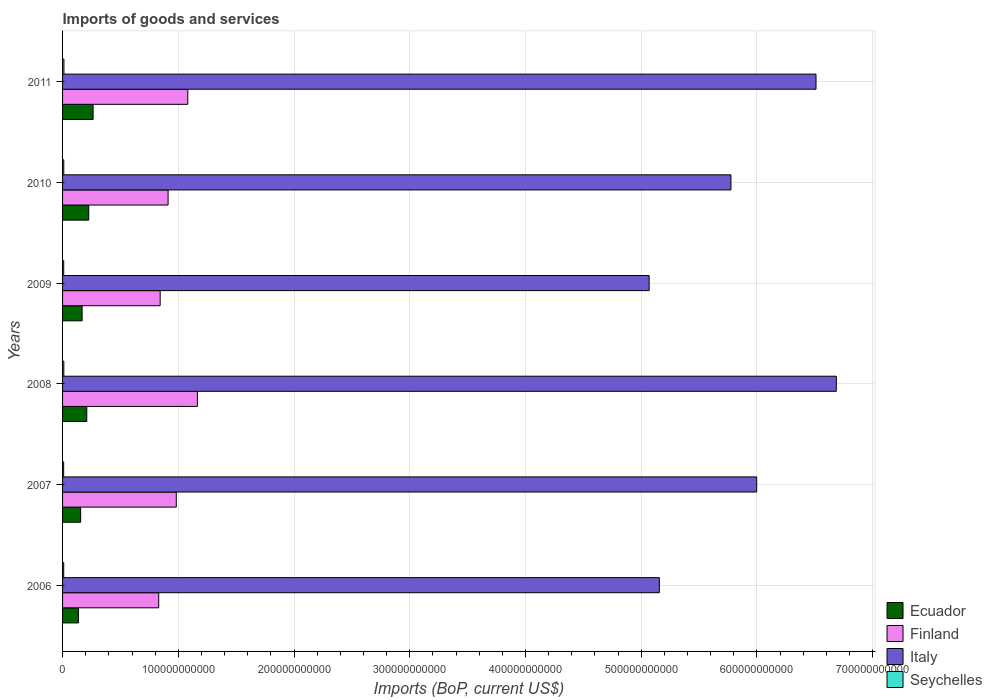How many different coloured bars are there?
Provide a short and direct response. 4. How many groups of bars are there?
Keep it short and to the point. 6. Are the number of bars per tick equal to the number of legend labels?
Give a very brief answer. Yes. How many bars are there on the 2nd tick from the top?
Keep it short and to the point. 4. What is the label of the 3rd group of bars from the top?
Offer a very short reply. 2009. In how many cases, is the number of bars for a given year not equal to the number of legend labels?
Offer a terse response. 0. What is the amount spent on imports in Ecuador in 2008?
Provide a succinct answer. 2.09e+1. Across all years, what is the maximum amount spent on imports in Finland?
Provide a short and direct response. 1.17e+11. Across all years, what is the minimum amount spent on imports in Ecuador?
Your answer should be very brief. 1.37e+1. In which year was the amount spent on imports in Finland minimum?
Offer a very short reply. 2006. What is the total amount spent on imports in Italy in the graph?
Keep it short and to the point. 3.52e+12. What is the difference between the amount spent on imports in Italy in 2007 and that in 2010?
Provide a short and direct response. 2.23e+1. What is the difference between the amount spent on imports in Finland in 2009 and the amount spent on imports in Italy in 2011?
Your response must be concise. -5.67e+11. What is the average amount spent on imports in Ecuador per year?
Give a very brief answer. 1.94e+1. In the year 2009, what is the difference between the amount spent on imports in Seychelles and amount spent on imports in Italy?
Keep it short and to the point. -5.06e+11. In how many years, is the amount spent on imports in Ecuador greater than 560000000000 US$?
Keep it short and to the point. 0. What is the ratio of the amount spent on imports in Ecuador in 2008 to that in 2009?
Keep it short and to the point. 1.24. Is the amount spent on imports in Seychelles in 2007 less than that in 2011?
Your answer should be very brief. Yes. Is the difference between the amount spent on imports in Seychelles in 2006 and 2008 greater than the difference between the amount spent on imports in Italy in 2006 and 2008?
Keep it short and to the point. Yes. What is the difference between the highest and the second highest amount spent on imports in Seychelles?
Your answer should be very brief. 9.66e+07. What is the difference between the highest and the lowest amount spent on imports in Ecuador?
Ensure brevity in your answer.  1.26e+1. Is it the case that in every year, the sum of the amount spent on imports in Seychelles and amount spent on imports in Finland is greater than the sum of amount spent on imports in Ecuador and amount spent on imports in Italy?
Make the answer very short. No. What does the 4th bar from the top in 2009 represents?
Make the answer very short. Ecuador. What does the 2nd bar from the bottom in 2008 represents?
Offer a very short reply. Finland. Is it the case that in every year, the sum of the amount spent on imports in Italy and amount spent on imports in Seychelles is greater than the amount spent on imports in Ecuador?
Your answer should be very brief. Yes. How many bars are there?
Give a very brief answer. 24. Are all the bars in the graph horizontal?
Offer a very short reply. Yes. How many years are there in the graph?
Provide a short and direct response. 6. What is the difference between two consecutive major ticks on the X-axis?
Provide a short and direct response. 1.00e+11. Does the graph contain any zero values?
Provide a succinct answer. No. Does the graph contain grids?
Offer a terse response. Yes. How many legend labels are there?
Your answer should be compact. 4. How are the legend labels stacked?
Your response must be concise. Vertical. What is the title of the graph?
Your response must be concise. Imports of goods and services. What is the label or title of the X-axis?
Your response must be concise. Imports (BoP, current US$). What is the Imports (BoP, current US$) in Ecuador in 2006?
Provide a succinct answer. 1.37e+1. What is the Imports (BoP, current US$) of Finland in 2006?
Provide a short and direct response. 8.31e+1. What is the Imports (BoP, current US$) of Italy in 2006?
Provide a succinct answer. 5.16e+11. What is the Imports (BoP, current US$) in Seychelles in 2006?
Ensure brevity in your answer.  9.85e+08. What is the Imports (BoP, current US$) in Ecuador in 2007?
Offer a very short reply. 1.56e+1. What is the Imports (BoP, current US$) of Finland in 2007?
Your response must be concise. 9.83e+1. What is the Imports (BoP, current US$) of Italy in 2007?
Provide a succinct answer. 6.00e+11. What is the Imports (BoP, current US$) in Seychelles in 2007?
Ensure brevity in your answer.  9.49e+08. What is the Imports (BoP, current US$) of Ecuador in 2008?
Give a very brief answer. 2.09e+1. What is the Imports (BoP, current US$) of Finland in 2008?
Offer a terse response. 1.17e+11. What is the Imports (BoP, current US$) in Italy in 2008?
Offer a terse response. 6.69e+11. What is the Imports (BoP, current US$) in Seychelles in 2008?
Offer a very short reply. 1.08e+09. What is the Imports (BoP, current US$) in Ecuador in 2009?
Your answer should be compact. 1.69e+1. What is the Imports (BoP, current US$) in Finland in 2009?
Make the answer very short. 8.43e+1. What is the Imports (BoP, current US$) in Italy in 2009?
Your response must be concise. 5.07e+11. What is the Imports (BoP, current US$) of Seychelles in 2009?
Offer a terse response. 9.92e+08. What is the Imports (BoP, current US$) of Ecuador in 2010?
Offer a terse response. 2.26e+1. What is the Imports (BoP, current US$) in Finland in 2010?
Provide a succinct answer. 9.12e+1. What is the Imports (BoP, current US$) of Italy in 2010?
Make the answer very short. 5.78e+11. What is the Imports (BoP, current US$) of Seychelles in 2010?
Provide a short and direct response. 1.05e+09. What is the Imports (BoP, current US$) in Ecuador in 2011?
Offer a very short reply. 2.64e+1. What is the Imports (BoP, current US$) of Finland in 2011?
Ensure brevity in your answer.  1.08e+11. What is the Imports (BoP, current US$) of Italy in 2011?
Keep it short and to the point. 6.51e+11. What is the Imports (BoP, current US$) in Seychelles in 2011?
Ensure brevity in your answer.  1.18e+09. Across all years, what is the maximum Imports (BoP, current US$) in Ecuador?
Your response must be concise. 2.64e+1. Across all years, what is the maximum Imports (BoP, current US$) of Finland?
Provide a succinct answer. 1.17e+11. Across all years, what is the maximum Imports (BoP, current US$) in Italy?
Make the answer very short. 6.69e+11. Across all years, what is the maximum Imports (BoP, current US$) in Seychelles?
Provide a short and direct response. 1.18e+09. Across all years, what is the minimum Imports (BoP, current US$) of Ecuador?
Offer a terse response. 1.37e+1. Across all years, what is the minimum Imports (BoP, current US$) in Finland?
Ensure brevity in your answer.  8.31e+1. Across all years, what is the minimum Imports (BoP, current US$) of Italy?
Make the answer very short. 5.07e+11. Across all years, what is the minimum Imports (BoP, current US$) of Seychelles?
Your answer should be very brief. 9.49e+08. What is the total Imports (BoP, current US$) in Ecuador in the graph?
Keep it short and to the point. 1.16e+11. What is the total Imports (BoP, current US$) in Finland in the graph?
Your answer should be very brief. 5.82e+11. What is the total Imports (BoP, current US$) in Italy in the graph?
Ensure brevity in your answer.  3.52e+12. What is the total Imports (BoP, current US$) in Seychelles in the graph?
Offer a very short reply. 6.24e+09. What is the difference between the Imports (BoP, current US$) of Ecuador in 2006 and that in 2007?
Give a very brief answer. -1.87e+09. What is the difference between the Imports (BoP, current US$) of Finland in 2006 and that in 2007?
Your response must be concise. -1.52e+1. What is the difference between the Imports (BoP, current US$) of Italy in 2006 and that in 2007?
Give a very brief answer. -8.41e+1. What is the difference between the Imports (BoP, current US$) in Seychelles in 2006 and that in 2007?
Provide a short and direct response. 3.58e+07. What is the difference between the Imports (BoP, current US$) in Ecuador in 2006 and that in 2008?
Give a very brief answer. -7.18e+09. What is the difference between the Imports (BoP, current US$) in Finland in 2006 and that in 2008?
Ensure brevity in your answer.  -3.34e+1. What is the difference between the Imports (BoP, current US$) of Italy in 2006 and that in 2008?
Provide a short and direct response. -1.53e+11. What is the difference between the Imports (BoP, current US$) in Seychelles in 2006 and that in 2008?
Keep it short and to the point. -9.99e+07. What is the difference between the Imports (BoP, current US$) of Ecuador in 2006 and that in 2009?
Your response must be concise. -3.14e+09. What is the difference between the Imports (BoP, current US$) in Finland in 2006 and that in 2009?
Your answer should be very brief. -1.26e+09. What is the difference between the Imports (BoP, current US$) of Italy in 2006 and that in 2009?
Keep it short and to the point. 8.82e+09. What is the difference between the Imports (BoP, current US$) in Seychelles in 2006 and that in 2009?
Provide a short and direct response. -7.03e+06. What is the difference between the Imports (BoP, current US$) in Ecuador in 2006 and that in 2010?
Give a very brief answer. -8.89e+09. What is the difference between the Imports (BoP, current US$) in Finland in 2006 and that in 2010?
Offer a very short reply. -8.11e+09. What is the difference between the Imports (BoP, current US$) in Italy in 2006 and that in 2010?
Provide a short and direct response. -6.18e+1. What is the difference between the Imports (BoP, current US$) of Seychelles in 2006 and that in 2010?
Your response must be concise. -6.32e+07. What is the difference between the Imports (BoP, current US$) of Ecuador in 2006 and that in 2011?
Your answer should be very brief. -1.26e+1. What is the difference between the Imports (BoP, current US$) of Finland in 2006 and that in 2011?
Your answer should be very brief. -2.51e+1. What is the difference between the Imports (BoP, current US$) in Italy in 2006 and that in 2011?
Offer a terse response. -1.35e+11. What is the difference between the Imports (BoP, current US$) in Seychelles in 2006 and that in 2011?
Your answer should be compact. -1.96e+08. What is the difference between the Imports (BoP, current US$) in Ecuador in 2007 and that in 2008?
Your response must be concise. -5.31e+09. What is the difference between the Imports (BoP, current US$) in Finland in 2007 and that in 2008?
Make the answer very short. -1.82e+1. What is the difference between the Imports (BoP, current US$) of Italy in 2007 and that in 2008?
Offer a very short reply. -6.88e+1. What is the difference between the Imports (BoP, current US$) in Seychelles in 2007 and that in 2008?
Give a very brief answer. -1.36e+08. What is the difference between the Imports (BoP, current US$) of Ecuador in 2007 and that in 2009?
Your answer should be compact. -1.27e+09. What is the difference between the Imports (BoP, current US$) in Finland in 2007 and that in 2009?
Your response must be concise. 1.39e+1. What is the difference between the Imports (BoP, current US$) of Italy in 2007 and that in 2009?
Your response must be concise. 9.29e+1. What is the difference between the Imports (BoP, current US$) in Seychelles in 2007 and that in 2009?
Provide a succinct answer. -4.29e+07. What is the difference between the Imports (BoP, current US$) of Ecuador in 2007 and that in 2010?
Provide a short and direct response. -7.02e+09. What is the difference between the Imports (BoP, current US$) in Finland in 2007 and that in 2010?
Keep it short and to the point. 7.09e+09. What is the difference between the Imports (BoP, current US$) in Italy in 2007 and that in 2010?
Provide a succinct answer. 2.23e+1. What is the difference between the Imports (BoP, current US$) of Seychelles in 2007 and that in 2010?
Offer a very short reply. -9.91e+07. What is the difference between the Imports (BoP, current US$) of Ecuador in 2007 and that in 2011?
Make the answer very short. -1.08e+1. What is the difference between the Imports (BoP, current US$) in Finland in 2007 and that in 2011?
Your answer should be very brief. -9.94e+09. What is the difference between the Imports (BoP, current US$) of Italy in 2007 and that in 2011?
Ensure brevity in your answer.  -5.13e+1. What is the difference between the Imports (BoP, current US$) of Seychelles in 2007 and that in 2011?
Give a very brief answer. -2.32e+08. What is the difference between the Imports (BoP, current US$) of Ecuador in 2008 and that in 2009?
Your response must be concise. 4.04e+09. What is the difference between the Imports (BoP, current US$) in Finland in 2008 and that in 2009?
Keep it short and to the point. 3.22e+1. What is the difference between the Imports (BoP, current US$) in Italy in 2008 and that in 2009?
Provide a succinct answer. 1.62e+11. What is the difference between the Imports (BoP, current US$) in Seychelles in 2008 and that in 2009?
Offer a very short reply. 9.28e+07. What is the difference between the Imports (BoP, current US$) in Ecuador in 2008 and that in 2010?
Your response must be concise. -1.71e+09. What is the difference between the Imports (BoP, current US$) in Finland in 2008 and that in 2010?
Keep it short and to the point. 2.53e+1. What is the difference between the Imports (BoP, current US$) of Italy in 2008 and that in 2010?
Make the answer very short. 9.11e+1. What is the difference between the Imports (BoP, current US$) in Seychelles in 2008 and that in 2010?
Your response must be concise. 3.67e+07. What is the difference between the Imports (BoP, current US$) in Ecuador in 2008 and that in 2011?
Your answer should be very brief. -5.47e+09. What is the difference between the Imports (BoP, current US$) of Finland in 2008 and that in 2011?
Offer a terse response. 8.29e+09. What is the difference between the Imports (BoP, current US$) in Italy in 2008 and that in 2011?
Your answer should be compact. 1.76e+1. What is the difference between the Imports (BoP, current US$) in Seychelles in 2008 and that in 2011?
Your response must be concise. -9.66e+07. What is the difference between the Imports (BoP, current US$) of Ecuador in 2009 and that in 2010?
Offer a very short reply. -5.75e+09. What is the difference between the Imports (BoP, current US$) in Finland in 2009 and that in 2010?
Your answer should be very brief. -6.85e+09. What is the difference between the Imports (BoP, current US$) in Italy in 2009 and that in 2010?
Offer a terse response. -7.07e+1. What is the difference between the Imports (BoP, current US$) of Seychelles in 2009 and that in 2010?
Offer a terse response. -5.62e+07. What is the difference between the Imports (BoP, current US$) of Ecuador in 2009 and that in 2011?
Offer a very short reply. -9.51e+09. What is the difference between the Imports (BoP, current US$) of Finland in 2009 and that in 2011?
Provide a succinct answer. -2.39e+1. What is the difference between the Imports (BoP, current US$) of Italy in 2009 and that in 2011?
Make the answer very short. -1.44e+11. What is the difference between the Imports (BoP, current US$) in Seychelles in 2009 and that in 2011?
Provide a short and direct response. -1.89e+08. What is the difference between the Imports (BoP, current US$) in Ecuador in 2010 and that in 2011?
Provide a succinct answer. -3.76e+09. What is the difference between the Imports (BoP, current US$) in Finland in 2010 and that in 2011?
Your answer should be very brief. -1.70e+1. What is the difference between the Imports (BoP, current US$) in Italy in 2010 and that in 2011?
Keep it short and to the point. -7.35e+1. What is the difference between the Imports (BoP, current US$) in Seychelles in 2010 and that in 2011?
Give a very brief answer. -1.33e+08. What is the difference between the Imports (BoP, current US$) in Ecuador in 2006 and the Imports (BoP, current US$) in Finland in 2007?
Keep it short and to the point. -8.45e+1. What is the difference between the Imports (BoP, current US$) of Ecuador in 2006 and the Imports (BoP, current US$) of Italy in 2007?
Give a very brief answer. -5.86e+11. What is the difference between the Imports (BoP, current US$) in Ecuador in 2006 and the Imports (BoP, current US$) in Seychelles in 2007?
Ensure brevity in your answer.  1.28e+1. What is the difference between the Imports (BoP, current US$) of Finland in 2006 and the Imports (BoP, current US$) of Italy in 2007?
Give a very brief answer. -5.17e+11. What is the difference between the Imports (BoP, current US$) in Finland in 2006 and the Imports (BoP, current US$) in Seychelles in 2007?
Your answer should be very brief. 8.21e+1. What is the difference between the Imports (BoP, current US$) in Italy in 2006 and the Imports (BoP, current US$) in Seychelles in 2007?
Keep it short and to the point. 5.15e+11. What is the difference between the Imports (BoP, current US$) in Ecuador in 2006 and the Imports (BoP, current US$) in Finland in 2008?
Your answer should be very brief. -1.03e+11. What is the difference between the Imports (BoP, current US$) in Ecuador in 2006 and the Imports (BoP, current US$) in Italy in 2008?
Offer a very short reply. -6.55e+11. What is the difference between the Imports (BoP, current US$) of Ecuador in 2006 and the Imports (BoP, current US$) of Seychelles in 2008?
Provide a short and direct response. 1.27e+1. What is the difference between the Imports (BoP, current US$) of Finland in 2006 and the Imports (BoP, current US$) of Italy in 2008?
Your response must be concise. -5.86e+11. What is the difference between the Imports (BoP, current US$) in Finland in 2006 and the Imports (BoP, current US$) in Seychelles in 2008?
Offer a terse response. 8.20e+1. What is the difference between the Imports (BoP, current US$) in Italy in 2006 and the Imports (BoP, current US$) in Seychelles in 2008?
Ensure brevity in your answer.  5.15e+11. What is the difference between the Imports (BoP, current US$) of Ecuador in 2006 and the Imports (BoP, current US$) of Finland in 2009?
Your answer should be compact. -7.06e+1. What is the difference between the Imports (BoP, current US$) in Ecuador in 2006 and the Imports (BoP, current US$) in Italy in 2009?
Your answer should be compact. -4.93e+11. What is the difference between the Imports (BoP, current US$) of Ecuador in 2006 and the Imports (BoP, current US$) of Seychelles in 2009?
Provide a short and direct response. 1.28e+1. What is the difference between the Imports (BoP, current US$) in Finland in 2006 and the Imports (BoP, current US$) in Italy in 2009?
Provide a succinct answer. -4.24e+11. What is the difference between the Imports (BoP, current US$) of Finland in 2006 and the Imports (BoP, current US$) of Seychelles in 2009?
Your answer should be very brief. 8.21e+1. What is the difference between the Imports (BoP, current US$) of Italy in 2006 and the Imports (BoP, current US$) of Seychelles in 2009?
Provide a succinct answer. 5.15e+11. What is the difference between the Imports (BoP, current US$) of Ecuador in 2006 and the Imports (BoP, current US$) of Finland in 2010?
Your answer should be very brief. -7.74e+1. What is the difference between the Imports (BoP, current US$) of Ecuador in 2006 and the Imports (BoP, current US$) of Italy in 2010?
Provide a succinct answer. -5.64e+11. What is the difference between the Imports (BoP, current US$) in Ecuador in 2006 and the Imports (BoP, current US$) in Seychelles in 2010?
Provide a succinct answer. 1.27e+1. What is the difference between the Imports (BoP, current US$) in Finland in 2006 and the Imports (BoP, current US$) in Italy in 2010?
Provide a succinct answer. -4.95e+11. What is the difference between the Imports (BoP, current US$) of Finland in 2006 and the Imports (BoP, current US$) of Seychelles in 2010?
Offer a terse response. 8.20e+1. What is the difference between the Imports (BoP, current US$) in Italy in 2006 and the Imports (BoP, current US$) in Seychelles in 2010?
Offer a terse response. 5.15e+11. What is the difference between the Imports (BoP, current US$) of Ecuador in 2006 and the Imports (BoP, current US$) of Finland in 2011?
Provide a succinct answer. -9.45e+1. What is the difference between the Imports (BoP, current US$) of Ecuador in 2006 and the Imports (BoP, current US$) of Italy in 2011?
Provide a succinct answer. -6.37e+11. What is the difference between the Imports (BoP, current US$) of Ecuador in 2006 and the Imports (BoP, current US$) of Seychelles in 2011?
Your answer should be very brief. 1.26e+1. What is the difference between the Imports (BoP, current US$) in Finland in 2006 and the Imports (BoP, current US$) in Italy in 2011?
Your answer should be compact. -5.68e+11. What is the difference between the Imports (BoP, current US$) in Finland in 2006 and the Imports (BoP, current US$) in Seychelles in 2011?
Give a very brief answer. 8.19e+1. What is the difference between the Imports (BoP, current US$) of Italy in 2006 and the Imports (BoP, current US$) of Seychelles in 2011?
Offer a terse response. 5.15e+11. What is the difference between the Imports (BoP, current US$) of Ecuador in 2007 and the Imports (BoP, current US$) of Finland in 2008?
Your answer should be compact. -1.01e+11. What is the difference between the Imports (BoP, current US$) in Ecuador in 2007 and the Imports (BoP, current US$) in Italy in 2008?
Offer a very short reply. -6.53e+11. What is the difference between the Imports (BoP, current US$) of Ecuador in 2007 and the Imports (BoP, current US$) of Seychelles in 2008?
Your answer should be compact. 1.45e+1. What is the difference between the Imports (BoP, current US$) in Finland in 2007 and the Imports (BoP, current US$) in Italy in 2008?
Your answer should be very brief. -5.70e+11. What is the difference between the Imports (BoP, current US$) of Finland in 2007 and the Imports (BoP, current US$) of Seychelles in 2008?
Your answer should be very brief. 9.72e+1. What is the difference between the Imports (BoP, current US$) of Italy in 2007 and the Imports (BoP, current US$) of Seychelles in 2008?
Your response must be concise. 5.99e+11. What is the difference between the Imports (BoP, current US$) of Ecuador in 2007 and the Imports (BoP, current US$) of Finland in 2009?
Offer a terse response. -6.87e+1. What is the difference between the Imports (BoP, current US$) in Ecuador in 2007 and the Imports (BoP, current US$) in Italy in 2009?
Keep it short and to the point. -4.91e+11. What is the difference between the Imports (BoP, current US$) of Ecuador in 2007 and the Imports (BoP, current US$) of Seychelles in 2009?
Give a very brief answer. 1.46e+1. What is the difference between the Imports (BoP, current US$) in Finland in 2007 and the Imports (BoP, current US$) in Italy in 2009?
Offer a very short reply. -4.09e+11. What is the difference between the Imports (BoP, current US$) of Finland in 2007 and the Imports (BoP, current US$) of Seychelles in 2009?
Offer a terse response. 9.73e+1. What is the difference between the Imports (BoP, current US$) in Italy in 2007 and the Imports (BoP, current US$) in Seychelles in 2009?
Make the answer very short. 5.99e+11. What is the difference between the Imports (BoP, current US$) in Ecuador in 2007 and the Imports (BoP, current US$) in Finland in 2010?
Offer a very short reply. -7.56e+1. What is the difference between the Imports (BoP, current US$) of Ecuador in 2007 and the Imports (BoP, current US$) of Italy in 2010?
Provide a succinct answer. -5.62e+11. What is the difference between the Imports (BoP, current US$) of Ecuador in 2007 and the Imports (BoP, current US$) of Seychelles in 2010?
Provide a succinct answer. 1.46e+1. What is the difference between the Imports (BoP, current US$) of Finland in 2007 and the Imports (BoP, current US$) of Italy in 2010?
Offer a terse response. -4.79e+11. What is the difference between the Imports (BoP, current US$) in Finland in 2007 and the Imports (BoP, current US$) in Seychelles in 2010?
Keep it short and to the point. 9.72e+1. What is the difference between the Imports (BoP, current US$) in Italy in 2007 and the Imports (BoP, current US$) in Seychelles in 2010?
Your answer should be compact. 5.99e+11. What is the difference between the Imports (BoP, current US$) of Ecuador in 2007 and the Imports (BoP, current US$) of Finland in 2011?
Your answer should be compact. -9.26e+1. What is the difference between the Imports (BoP, current US$) in Ecuador in 2007 and the Imports (BoP, current US$) in Italy in 2011?
Give a very brief answer. -6.36e+11. What is the difference between the Imports (BoP, current US$) of Ecuador in 2007 and the Imports (BoP, current US$) of Seychelles in 2011?
Your response must be concise. 1.44e+1. What is the difference between the Imports (BoP, current US$) in Finland in 2007 and the Imports (BoP, current US$) in Italy in 2011?
Offer a very short reply. -5.53e+11. What is the difference between the Imports (BoP, current US$) of Finland in 2007 and the Imports (BoP, current US$) of Seychelles in 2011?
Your response must be concise. 9.71e+1. What is the difference between the Imports (BoP, current US$) in Italy in 2007 and the Imports (BoP, current US$) in Seychelles in 2011?
Offer a very short reply. 5.99e+11. What is the difference between the Imports (BoP, current US$) of Ecuador in 2008 and the Imports (BoP, current US$) of Finland in 2009?
Provide a short and direct response. -6.34e+1. What is the difference between the Imports (BoP, current US$) in Ecuador in 2008 and the Imports (BoP, current US$) in Italy in 2009?
Your response must be concise. -4.86e+11. What is the difference between the Imports (BoP, current US$) in Ecuador in 2008 and the Imports (BoP, current US$) in Seychelles in 2009?
Offer a very short reply. 1.99e+1. What is the difference between the Imports (BoP, current US$) in Finland in 2008 and the Imports (BoP, current US$) in Italy in 2009?
Give a very brief answer. -3.90e+11. What is the difference between the Imports (BoP, current US$) in Finland in 2008 and the Imports (BoP, current US$) in Seychelles in 2009?
Keep it short and to the point. 1.16e+11. What is the difference between the Imports (BoP, current US$) in Italy in 2008 and the Imports (BoP, current US$) in Seychelles in 2009?
Your response must be concise. 6.68e+11. What is the difference between the Imports (BoP, current US$) of Ecuador in 2008 and the Imports (BoP, current US$) of Finland in 2010?
Offer a terse response. -7.03e+1. What is the difference between the Imports (BoP, current US$) of Ecuador in 2008 and the Imports (BoP, current US$) of Italy in 2010?
Your response must be concise. -5.57e+11. What is the difference between the Imports (BoP, current US$) of Ecuador in 2008 and the Imports (BoP, current US$) of Seychelles in 2010?
Offer a very short reply. 1.99e+1. What is the difference between the Imports (BoP, current US$) in Finland in 2008 and the Imports (BoP, current US$) in Italy in 2010?
Provide a succinct answer. -4.61e+11. What is the difference between the Imports (BoP, current US$) of Finland in 2008 and the Imports (BoP, current US$) of Seychelles in 2010?
Keep it short and to the point. 1.15e+11. What is the difference between the Imports (BoP, current US$) of Italy in 2008 and the Imports (BoP, current US$) of Seychelles in 2010?
Give a very brief answer. 6.68e+11. What is the difference between the Imports (BoP, current US$) in Ecuador in 2008 and the Imports (BoP, current US$) in Finland in 2011?
Your answer should be very brief. -8.73e+1. What is the difference between the Imports (BoP, current US$) of Ecuador in 2008 and the Imports (BoP, current US$) of Italy in 2011?
Your answer should be compact. -6.30e+11. What is the difference between the Imports (BoP, current US$) in Ecuador in 2008 and the Imports (BoP, current US$) in Seychelles in 2011?
Make the answer very short. 1.97e+1. What is the difference between the Imports (BoP, current US$) of Finland in 2008 and the Imports (BoP, current US$) of Italy in 2011?
Your response must be concise. -5.35e+11. What is the difference between the Imports (BoP, current US$) of Finland in 2008 and the Imports (BoP, current US$) of Seychelles in 2011?
Ensure brevity in your answer.  1.15e+11. What is the difference between the Imports (BoP, current US$) of Italy in 2008 and the Imports (BoP, current US$) of Seychelles in 2011?
Make the answer very short. 6.68e+11. What is the difference between the Imports (BoP, current US$) of Ecuador in 2009 and the Imports (BoP, current US$) of Finland in 2010?
Your response must be concise. -7.43e+1. What is the difference between the Imports (BoP, current US$) in Ecuador in 2009 and the Imports (BoP, current US$) in Italy in 2010?
Your answer should be very brief. -5.61e+11. What is the difference between the Imports (BoP, current US$) in Ecuador in 2009 and the Imports (BoP, current US$) in Seychelles in 2010?
Offer a terse response. 1.58e+1. What is the difference between the Imports (BoP, current US$) of Finland in 2009 and the Imports (BoP, current US$) of Italy in 2010?
Keep it short and to the point. -4.93e+11. What is the difference between the Imports (BoP, current US$) in Finland in 2009 and the Imports (BoP, current US$) in Seychelles in 2010?
Keep it short and to the point. 8.33e+1. What is the difference between the Imports (BoP, current US$) of Italy in 2009 and the Imports (BoP, current US$) of Seychelles in 2010?
Provide a short and direct response. 5.06e+11. What is the difference between the Imports (BoP, current US$) in Ecuador in 2009 and the Imports (BoP, current US$) in Finland in 2011?
Your response must be concise. -9.13e+1. What is the difference between the Imports (BoP, current US$) of Ecuador in 2009 and the Imports (BoP, current US$) of Italy in 2011?
Give a very brief answer. -6.34e+11. What is the difference between the Imports (BoP, current US$) in Ecuador in 2009 and the Imports (BoP, current US$) in Seychelles in 2011?
Give a very brief answer. 1.57e+1. What is the difference between the Imports (BoP, current US$) in Finland in 2009 and the Imports (BoP, current US$) in Italy in 2011?
Your answer should be very brief. -5.67e+11. What is the difference between the Imports (BoP, current US$) of Finland in 2009 and the Imports (BoP, current US$) of Seychelles in 2011?
Ensure brevity in your answer.  8.32e+1. What is the difference between the Imports (BoP, current US$) of Italy in 2009 and the Imports (BoP, current US$) of Seychelles in 2011?
Your answer should be very brief. 5.06e+11. What is the difference between the Imports (BoP, current US$) of Ecuador in 2010 and the Imports (BoP, current US$) of Finland in 2011?
Keep it short and to the point. -8.56e+1. What is the difference between the Imports (BoP, current US$) of Ecuador in 2010 and the Imports (BoP, current US$) of Italy in 2011?
Your answer should be compact. -6.28e+11. What is the difference between the Imports (BoP, current US$) of Ecuador in 2010 and the Imports (BoP, current US$) of Seychelles in 2011?
Your answer should be compact. 2.15e+1. What is the difference between the Imports (BoP, current US$) in Finland in 2010 and the Imports (BoP, current US$) in Italy in 2011?
Ensure brevity in your answer.  -5.60e+11. What is the difference between the Imports (BoP, current US$) in Finland in 2010 and the Imports (BoP, current US$) in Seychelles in 2011?
Provide a short and direct response. 9.00e+1. What is the difference between the Imports (BoP, current US$) of Italy in 2010 and the Imports (BoP, current US$) of Seychelles in 2011?
Keep it short and to the point. 5.76e+11. What is the average Imports (BoP, current US$) in Ecuador per year?
Your answer should be compact. 1.94e+1. What is the average Imports (BoP, current US$) of Finland per year?
Give a very brief answer. 9.69e+1. What is the average Imports (BoP, current US$) of Italy per year?
Offer a very short reply. 5.87e+11. What is the average Imports (BoP, current US$) in Seychelles per year?
Offer a terse response. 1.04e+09. In the year 2006, what is the difference between the Imports (BoP, current US$) of Ecuador and Imports (BoP, current US$) of Finland?
Provide a short and direct response. -6.93e+1. In the year 2006, what is the difference between the Imports (BoP, current US$) in Ecuador and Imports (BoP, current US$) in Italy?
Give a very brief answer. -5.02e+11. In the year 2006, what is the difference between the Imports (BoP, current US$) of Ecuador and Imports (BoP, current US$) of Seychelles?
Your answer should be very brief. 1.28e+1. In the year 2006, what is the difference between the Imports (BoP, current US$) in Finland and Imports (BoP, current US$) in Italy?
Ensure brevity in your answer.  -4.33e+11. In the year 2006, what is the difference between the Imports (BoP, current US$) in Finland and Imports (BoP, current US$) in Seychelles?
Keep it short and to the point. 8.21e+1. In the year 2006, what is the difference between the Imports (BoP, current US$) of Italy and Imports (BoP, current US$) of Seychelles?
Provide a succinct answer. 5.15e+11. In the year 2007, what is the difference between the Imports (BoP, current US$) of Ecuador and Imports (BoP, current US$) of Finland?
Offer a very short reply. -8.27e+1. In the year 2007, what is the difference between the Imports (BoP, current US$) of Ecuador and Imports (BoP, current US$) of Italy?
Provide a succinct answer. -5.84e+11. In the year 2007, what is the difference between the Imports (BoP, current US$) in Ecuador and Imports (BoP, current US$) in Seychelles?
Give a very brief answer. 1.47e+1. In the year 2007, what is the difference between the Imports (BoP, current US$) of Finland and Imports (BoP, current US$) of Italy?
Your answer should be very brief. -5.02e+11. In the year 2007, what is the difference between the Imports (BoP, current US$) of Finland and Imports (BoP, current US$) of Seychelles?
Your answer should be compact. 9.73e+1. In the year 2007, what is the difference between the Imports (BoP, current US$) of Italy and Imports (BoP, current US$) of Seychelles?
Ensure brevity in your answer.  5.99e+11. In the year 2008, what is the difference between the Imports (BoP, current US$) in Ecuador and Imports (BoP, current US$) in Finland?
Your answer should be very brief. -9.56e+1. In the year 2008, what is the difference between the Imports (BoP, current US$) in Ecuador and Imports (BoP, current US$) in Italy?
Your answer should be very brief. -6.48e+11. In the year 2008, what is the difference between the Imports (BoP, current US$) of Ecuador and Imports (BoP, current US$) of Seychelles?
Make the answer very short. 1.98e+1. In the year 2008, what is the difference between the Imports (BoP, current US$) in Finland and Imports (BoP, current US$) in Italy?
Provide a short and direct response. -5.52e+11. In the year 2008, what is the difference between the Imports (BoP, current US$) of Finland and Imports (BoP, current US$) of Seychelles?
Your answer should be compact. 1.15e+11. In the year 2008, what is the difference between the Imports (BoP, current US$) in Italy and Imports (BoP, current US$) in Seychelles?
Offer a very short reply. 6.68e+11. In the year 2009, what is the difference between the Imports (BoP, current US$) of Ecuador and Imports (BoP, current US$) of Finland?
Your answer should be very brief. -6.75e+1. In the year 2009, what is the difference between the Imports (BoP, current US$) of Ecuador and Imports (BoP, current US$) of Italy?
Provide a succinct answer. -4.90e+11. In the year 2009, what is the difference between the Imports (BoP, current US$) of Ecuador and Imports (BoP, current US$) of Seychelles?
Keep it short and to the point. 1.59e+1. In the year 2009, what is the difference between the Imports (BoP, current US$) in Finland and Imports (BoP, current US$) in Italy?
Provide a short and direct response. -4.23e+11. In the year 2009, what is the difference between the Imports (BoP, current US$) in Finland and Imports (BoP, current US$) in Seychelles?
Provide a succinct answer. 8.34e+1. In the year 2009, what is the difference between the Imports (BoP, current US$) of Italy and Imports (BoP, current US$) of Seychelles?
Ensure brevity in your answer.  5.06e+11. In the year 2010, what is the difference between the Imports (BoP, current US$) of Ecuador and Imports (BoP, current US$) of Finland?
Keep it short and to the point. -6.86e+1. In the year 2010, what is the difference between the Imports (BoP, current US$) in Ecuador and Imports (BoP, current US$) in Italy?
Your answer should be compact. -5.55e+11. In the year 2010, what is the difference between the Imports (BoP, current US$) of Ecuador and Imports (BoP, current US$) of Seychelles?
Offer a terse response. 2.16e+1. In the year 2010, what is the difference between the Imports (BoP, current US$) of Finland and Imports (BoP, current US$) of Italy?
Your response must be concise. -4.86e+11. In the year 2010, what is the difference between the Imports (BoP, current US$) in Finland and Imports (BoP, current US$) in Seychelles?
Your answer should be compact. 9.02e+1. In the year 2010, what is the difference between the Imports (BoP, current US$) of Italy and Imports (BoP, current US$) of Seychelles?
Your answer should be very brief. 5.77e+11. In the year 2011, what is the difference between the Imports (BoP, current US$) of Ecuador and Imports (BoP, current US$) of Finland?
Your answer should be compact. -8.18e+1. In the year 2011, what is the difference between the Imports (BoP, current US$) of Ecuador and Imports (BoP, current US$) of Italy?
Offer a very short reply. -6.25e+11. In the year 2011, what is the difference between the Imports (BoP, current US$) of Ecuador and Imports (BoP, current US$) of Seychelles?
Provide a short and direct response. 2.52e+1. In the year 2011, what is the difference between the Imports (BoP, current US$) of Finland and Imports (BoP, current US$) of Italy?
Provide a succinct answer. -5.43e+11. In the year 2011, what is the difference between the Imports (BoP, current US$) in Finland and Imports (BoP, current US$) in Seychelles?
Offer a terse response. 1.07e+11. In the year 2011, what is the difference between the Imports (BoP, current US$) in Italy and Imports (BoP, current US$) in Seychelles?
Ensure brevity in your answer.  6.50e+11. What is the ratio of the Imports (BoP, current US$) in Ecuador in 2006 to that in 2007?
Offer a terse response. 0.88. What is the ratio of the Imports (BoP, current US$) of Finland in 2006 to that in 2007?
Ensure brevity in your answer.  0.85. What is the ratio of the Imports (BoP, current US$) in Italy in 2006 to that in 2007?
Offer a terse response. 0.86. What is the ratio of the Imports (BoP, current US$) in Seychelles in 2006 to that in 2007?
Ensure brevity in your answer.  1.04. What is the ratio of the Imports (BoP, current US$) in Ecuador in 2006 to that in 2008?
Provide a short and direct response. 0.66. What is the ratio of the Imports (BoP, current US$) of Finland in 2006 to that in 2008?
Make the answer very short. 0.71. What is the ratio of the Imports (BoP, current US$) in Italy in 2006 to that in 2008?
Provide a short and direct response. 0.77. What is the ratio of the Imports (BoP, current US$) of Seychelles in 2006 to that in 2008?
Ensure brevity in your answer.  0.91. What is the ratio of the Imports (BoP, current US$) in Ecuador in 2006 to that in 2009?
Your answer should be very brief. 0.81. What is the ratio of the Imports (BoP, current US$) of Finland in 2006 to that in 2009?
Make the answer very short. 0.99. What is the ratio of the Imports (BoP, current US$) in Italy in 2006 to that in 2009?
Provide a succinct answer. 1.02. What is the ratio of the Imports (BoP, current US$) in Seychelles in 2006 to that in 2009?
Offer a terse response. 0.99. What is the ratio of the Imports (BoP, current US$) of Ecuador in 2006 to that in 2010?
Your response must be concise. 0.61. What is the ratio of the Imports (BoP, current US$) of Finland in 2006 to that in 2010?
Your answer should be compact. 0.91. What is the ratio of the Imports (BoP, current US$) of Italy in 2006 to that in 2010?
Your response must be concise. 0.89. What is the ratio of the Imports (BoP, current US$) of Seychelles in 2006 to that in 2010?
Make the answer very short. 0.94. What is the ratio of the Imports (BoP, current US$) in Ecuador in 2006 to that in 2011?
Your answer should be very brief. 0.52. What is the ratio of the Imports (BoP, current US$) of Finland in 2006 to that in 2011?
Give a very brief answer. 0.77. What is the ratio of the Imports (BoP, current US$) of Italy in 2006 to that in 2011?
Provide a short and direct response. 0.79. What is the ratio of the Imports (BoP, current US$) of Seychelles in 2006 to that in 2011?
Keep it short and to the point. 0.83. What is the ratio of the Imports (BoP, current US$) of Ecuador in 2007 to that in 2008?
Make the answer very short. 0.75. What is the ratio of the Imports (BoP, current US$) of Finland in 2007 to that in 2008?
Give a very brief answer. 0.84. What is the ratio of the Imports (BoP, current US$) in Italy in 2007 to that in 2008?
Provide a succinct answer. 0.9. What is the ratio of the Imports (BoP, current US$) of Seychelles in 2007 to that in 2008?
Your answer should be compact. 0.87. What is the ratio of the Imports (BoP, current US$) of Ecuador in 2007 to that in 2009?
Provide a succinct answer. 0.92. What is the ratio of the Imports (BoP, current US$) in Finland in 2007 to that in 2009?
Keep it short and to the point. 1.17. What is the ratio of the Imports (BoP, current US$) in Italy in 2007 to that in 2009?
Your answer should be very brief. 1.18. What is the ratio of the Imports (BoP, current US$) of Seychelles in 2007 to that in 2009?
Your response must be concise. 0.96. What is the ratio of the Imports (BoP, current US$) of Ecuador in 2007 to that in 2010?
Keep it short and to the point. 0.69. What is the ratio of the Imports (BoP, current US$) in Finland in 2007 to that in 2010?
Offer a terse response. 1.08. What is the ratio of the Imports (BoP, current US$) in Italy in 2007 to that in 2010?
Provide a succinct answer. 1.04. What is the ratio of the Imports (BoP, current US$) of Seychelles in 2007 to that in 2010?
Your answer should be compact. 0.91. What is the ratio of the Imports (BoP, current US$) of Ecuador in 2007 to that in 2011?
Offer a terse response. 0.59. What is the ratio of the Imports (BoP, current US$) in Finland in 2007 to that in 2011?
Make the answer very short. 0.91. What is the ratio of the Imports (BoP, current US$) in Italy in 2007 to that in 2011?
Your answer should be very brief. 0.92. What is the ratio of the Imports (BoP, current US$) in Seychelles in 2007 to that in 2011?
Your answer should be compact. 0.8. What is the ratio of the Imports (BoP, current US$) of Ecuador in 2008 to that in 2009?
Make the answer very short. 1.24. What is the ratio of the Imports (BoP, current US$) in Finland in 2008 to that in 2009?
Offer a very short reply. 1.38. What is the ratio of the Imports (BoP, current US$) of Italy in 2008 to that in 2009?
Give a very brief answer. 1.32. What is the ratio of the Imports (BoP, current US$) in Seychelles in 2008 to that in 2009?
Provide a short and direct response. 1.09. What is the ratio of the Imports (BoP, current US$) in Ecuador in 2008 to that in 2010?
Offer a terse response. 0.92. What is the ratio of the Imports (BoP, current US$) in Finland in 2008 to that in 2010?
Give a very brief answer. 1.28. What is the ratio of the Imports (BoP, current US$) in Italy in 2008 to that in 2010?
Offer a very short reply. 1.16. What is the ratio of the Imports (BoP, current US$) of Seychelles in 2008 to that in 2010?
Make the answer very short. 1.03. What is the ratio of the Imports (BoP, current US$) in Ecuador in 2008 to that in 2011?
Your answer should be compact. 0.79. What is the ratio of the Imports (BoP, current US$) of Finland in 2008 to that in 2011?
Make the answer very short. 1.08. What is the ratio of the Imports (BoP, current US$) of Seychelles in 2008 to that in 2011?
Offer a very short reply. 0.92. What is the ratio of the Imports (BoP, current US$) in Ecuador in 2009 to that in 2010?
Give a very brief answer. 0.75. What is the ratio of the Imports (BoP, current US$) in Finland in 2009 to that in 2010?
Make the answer very short. 0.92. What is the ratio of the Imports (BoP, current US$) in Italy in 2009 to that in 2010?
Ensure brevity in your answer.  0.88. What is the ratio of the Imports (BoP, current US$) in Seychelles in 2009 to that in 2010?
Provide a succinct answer. 0.95. What is the ratio of the Imports (BoP, current US$) of Ecuador in 2009 to that in 2011?
Provide a short and direct response. 0.64. What is the ratio of the Imports (BoP, current US$) in Finland in 2009 to that in 2011?
Keep it short and to the point. 0.78. What is the ratio of the Imports (BoP, current US$) of Italy in 2009 to that in 2011?
Ensure brevity in your answer.  0.78. What is the ratio of the Imports (BoP, current US$) in Seychelles in 2009 to that in 2011?
Provide a short and direct response. 0.84. What is the ratio of the Imports (BoP, current US$) of Ecuador in 2010 to that in 2011?
Provide a succinct answer. 0.86. What is the ratio of the Imports (BoP, current US$) of Finland in 2010 to that in 2011?
Ensure brevity in your answer.  0.84. What is the ratio of the Imports (BoP, current US$) in Italy in 2010 to that in 2011?
Give a very brief answer. 0.89. What is the ratio of the Imports (BoP, current US$) in Seychelles in 2010 to that in 2011?
Ensure brevity in your answer.  0.89. What is the difference between the highest and the second highest Imports (BoP, current US$) in Ecuador?
Provide a short and direct response. 3.76e+09. What is the difference between the highest and the second highest Imports (BoP, current US$) in Finland?
Your answer should be very brief. 8.29e+09. What is the difference between the highest and the second highest Imports (BoP, current US$) in Italy?
Your answer should be very brief. 1.76e+1. What is the difference between the highest and the second highest Imports (BoP, current US$) of Seychelles?
Provide a short and direct response. 9.66e+07. What is the difference between the highest and the lowest Imports (BoP, current US$) of Ecuador?
Offer a very short reply. 1.26e+1. What is the difference between the highest and the lowest Imports (BoP, current US$) of Finland?
Make the answer very short. 3.34e+1. What is the difference between the highest and the lowest Imports (BoP, current US$) in Italy?
Offer a very short reply. 1.62e+11. What is the difference between the highest and the lowest Imports (BoP, current US$) of Seychelles?
Give a very brief answer. 2.32e+08. 